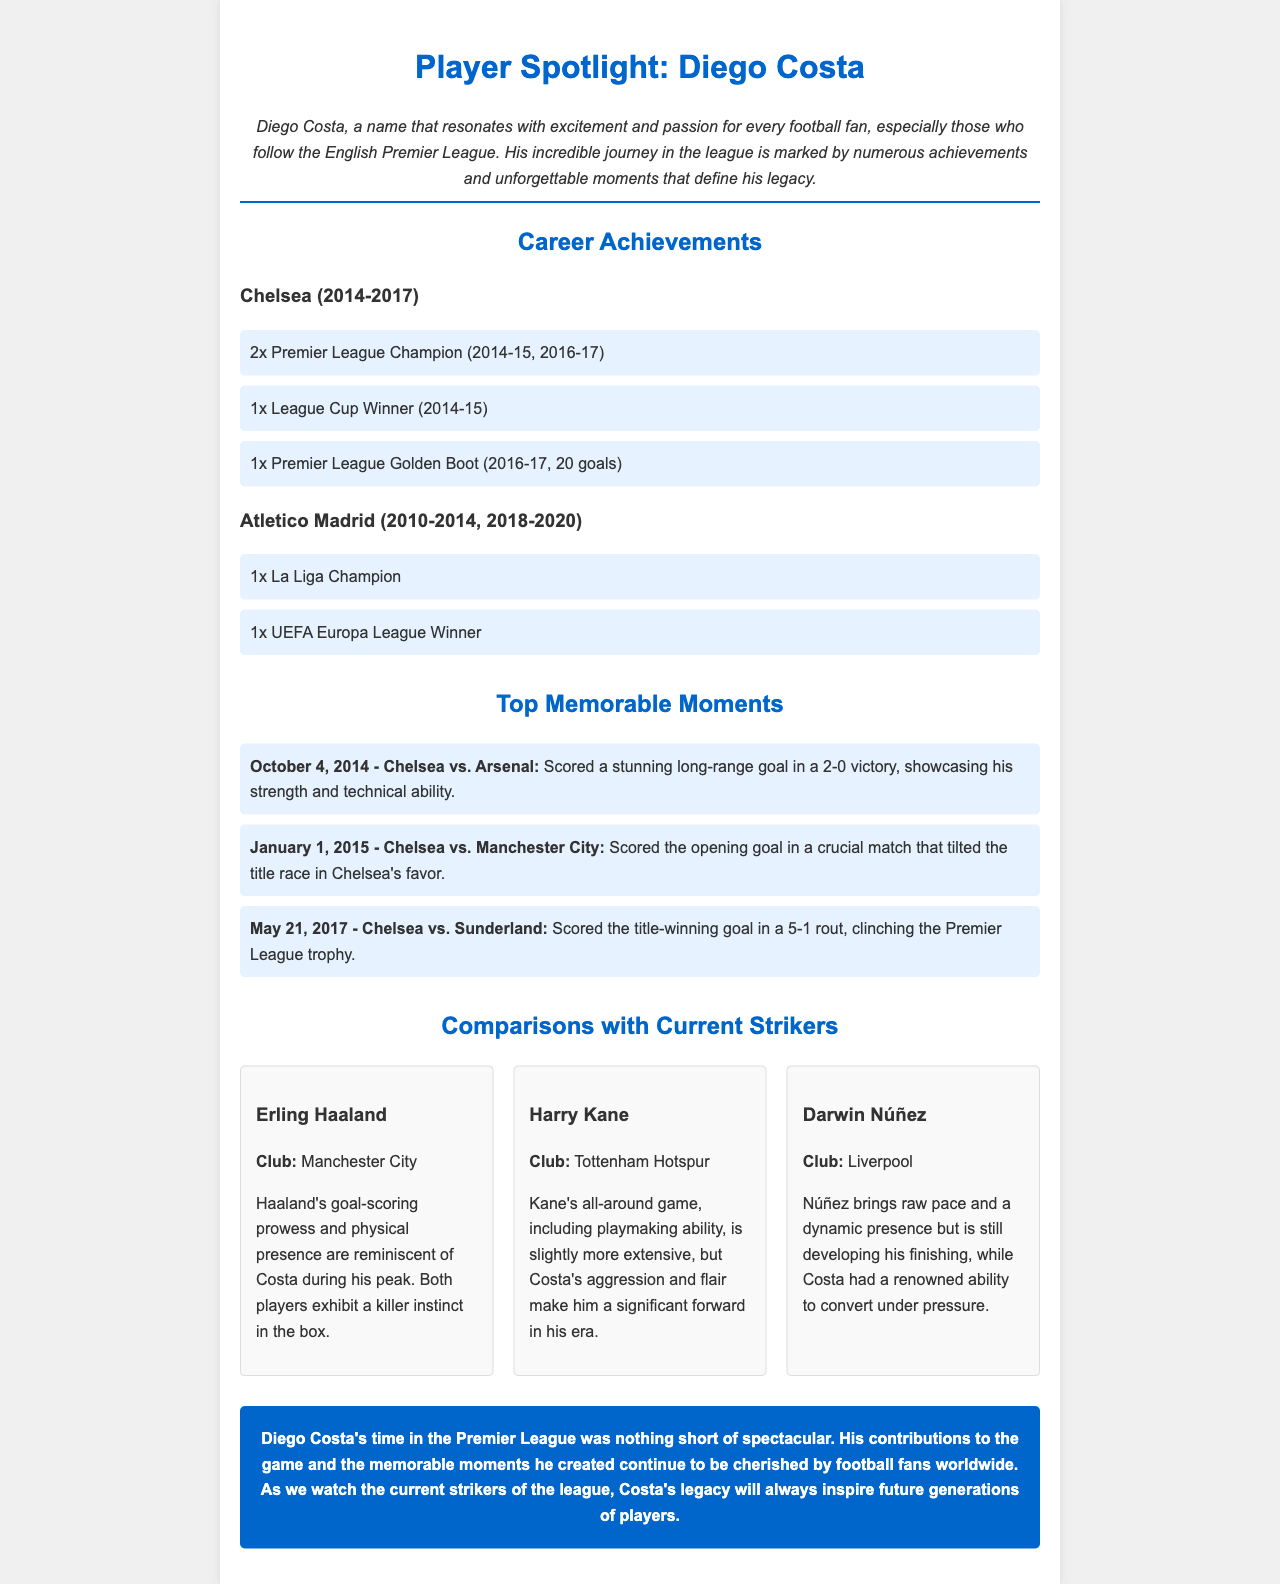What years did Diego Costa play for Chelsea? The document states that Diego Costa played for Chelsea from 2014 to 2017.
Answer: 2014-2017 How many Premier League titles did Costa win with Chelsea? According to the achievements section, Costa won 2 Premier League titles while at Chelsea.
Answer: 2 What was Diego Costa's total goals for the Premier League Golden Boot? The document indicates that Costa scored 20 goals to win the Premier League Golden Boot in the 2016-17 season.
Answer: 20 goals What memorable goal did Costa score against Arsenal? The document mentions that Costa scored a stunning long-range goal in a match against Arsenal on October 4, 2014.
Answer: Long-range goal against Arsenal Which current striker is compared to Costa for having a killer instinct in the box? The document states that Erling Haaland is compared to Costa for his goal-scoring prowess and physical presence.
Answer: Erling Haaland How many achievements are listed under Atletico Madrid for Costa? The document presents two achievements for Costa during his time with Atletico Madrid.
Answer: 2 What was the title of the newsletter? The title of the newsletter is found at the beginning of the document.
Answer: Player Spotlight: Diego Costa Which club does Harry Kane play for? The document specifically mentions that Harry Kane plays for Tottenham Hotspur.
Answer: Tottenham Hotspur 